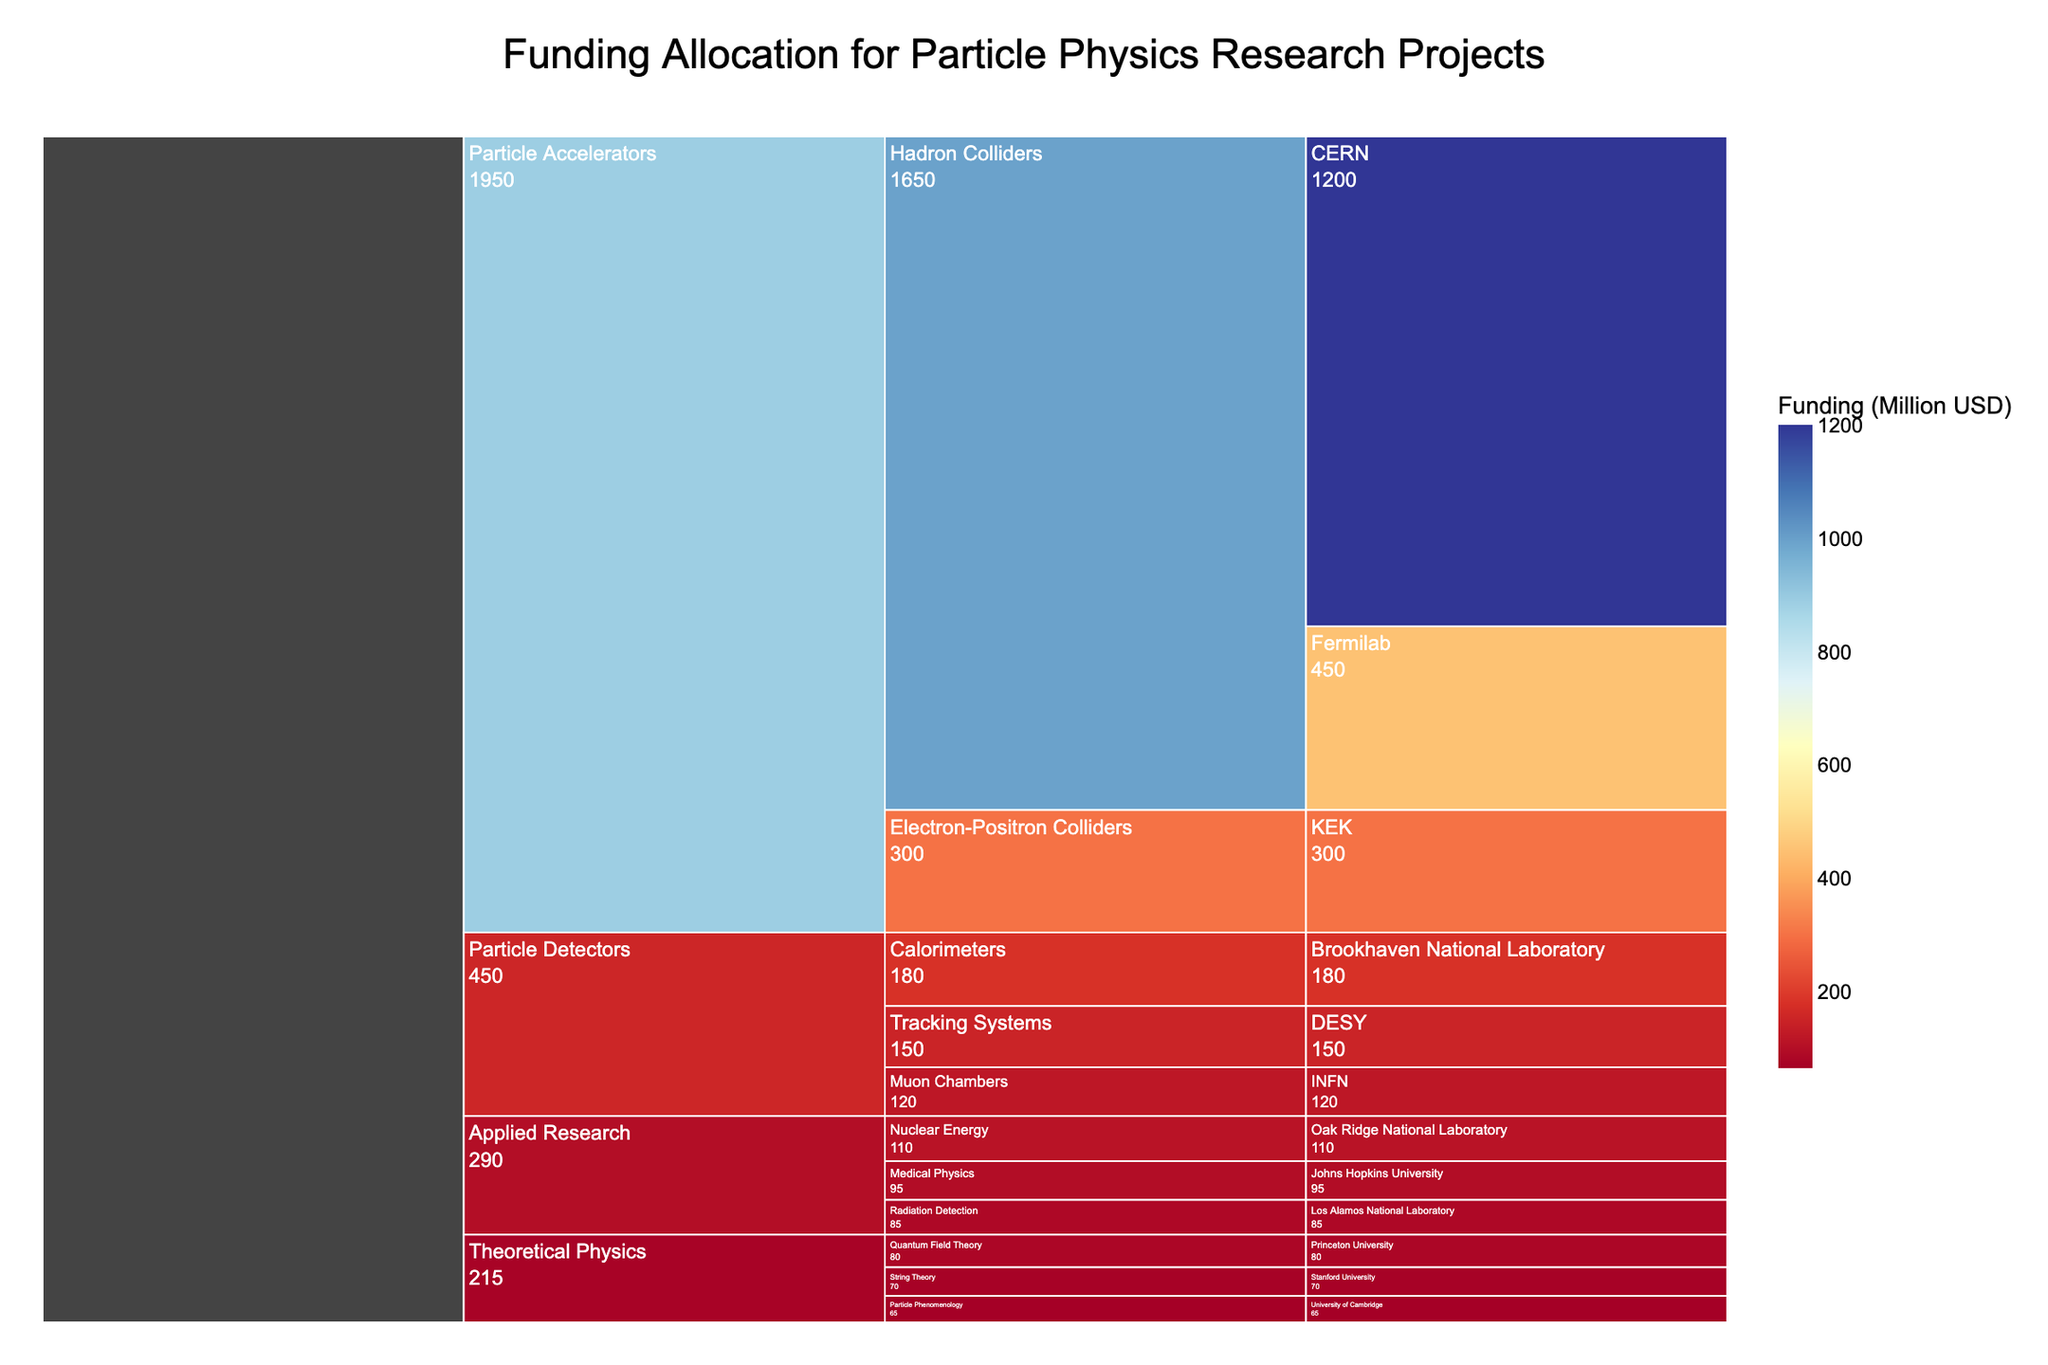What is the total funding allocated to the Particle Accelerators category? To find the total funding for the Particle Accelerators category, sum the funding across all subcategories and institutions within this category: (1200 + 450 + 300) = 1950 million USD.
Answer: 1950 million USD Which institution received the highest funding? Look for the institution with the highest funding value displayed in the figure. CERN received 1200 million USD, which is the highest amount.
Answer: CERN How much more funding does CERN receive compared to Fermilab? Subtract Fermilab's funding from CERN's: 1200 million USD (CERN) - 450 million USD (Fermilab) = 750 million USD.
Answer: 750 million USD What is the funding for subcategories within Particle Detectors? Sum the funding for all the subcategories within Particle Detectors: (180 + 150 + 120) = 450 million USD.
Answer: 450 million USD Which subcategory within Applied Research receives the least funding, and how much is it? From the Applied Research funding values, the least funding is given to Radiation Detection: 85 million USD.
Answer: Radiation Detection, 85 million USD Compare the funding between Theoretical Physics and Applied Research categories. Which one receives more and by how much? Total funding for Theoretical Physics is (80 + 70 + 65) = 215 million USD. Total funding for Applied Research is (95 + 110 + 85) = 290 million USD. The difference is 290 million USD - 215 million USD = 75 million USD, with Applied Research receiving more.
Answer: Applied Research, 75 million USD What is the average funding for institutions within Particle Accelerators? The funding amounts are 1200, 450, and 300. The average is (1200 + 450 + 300) / 3 = 650 million USD.
Answer: 650 million USD Identify a subcategory where a single institution receives all its funding, and state the amount and institution. The subcategory "Electron-Positron Colliders" within Particle Accelerators is funded only by KEK with 300 million USD.
Answer: Electron-Positron Colliders, KEK, 300 million USD What is the funding distribution among different subcategories within Theoretical Physics? The funding distribution is: Quantum Field Theory (80 million USD), String Theory (70 million USD), Particle Phenomenology (65 million USD).
Answer: Quantum Field Theory: 80 million USD, String Theory: 70 million USD, Particle Phenomenology: 65 million USD 